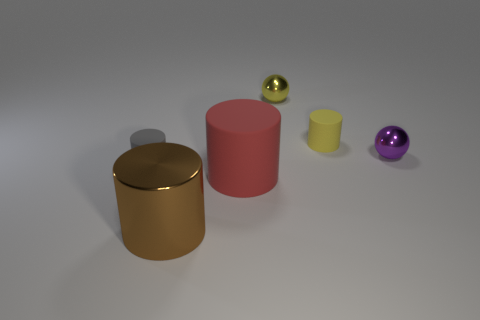There is a matte object that is behind the tiny gray object; is it the same shape as the red thing in front of the yellow rubber cylinder? Yes, the matte object behind the tiny gray sphere does indeed share the same cylindrical shape as the red object situated in front of the yellow cylinder. Both objects possess a circular base and rise vertically with a consistent diameter, typical characteristics of a cylindrical shape. 